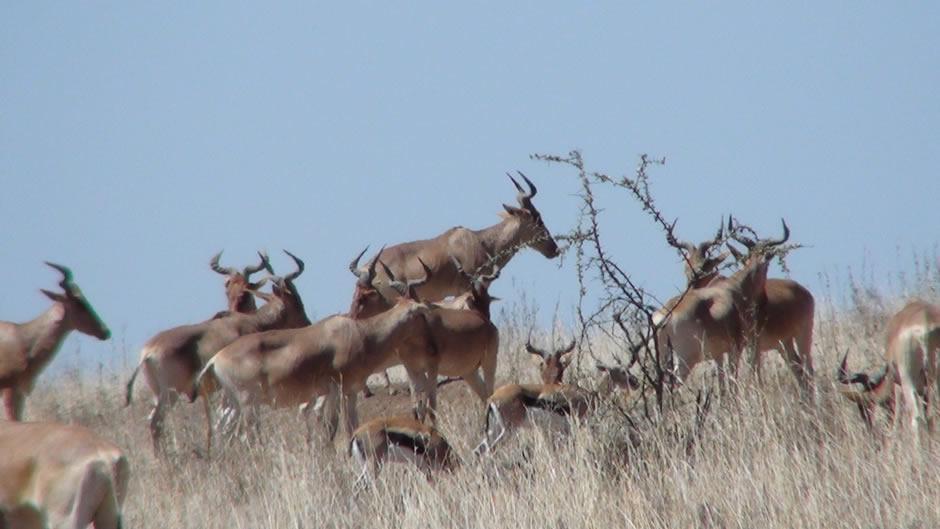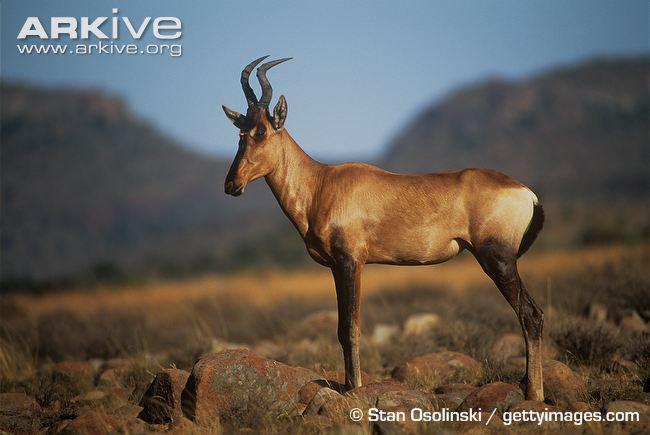The first image is the image on the left, the second image is the image on the right. Considering the images on both sides, is "One of the images includes a single animal." valid? Answer yes or no. Yes. The first image is the image on the left, the second image is the image on the right. For the images shown, is this caption "There are baby antelope in the image on the left." true? Answer yes or no. Yes. 